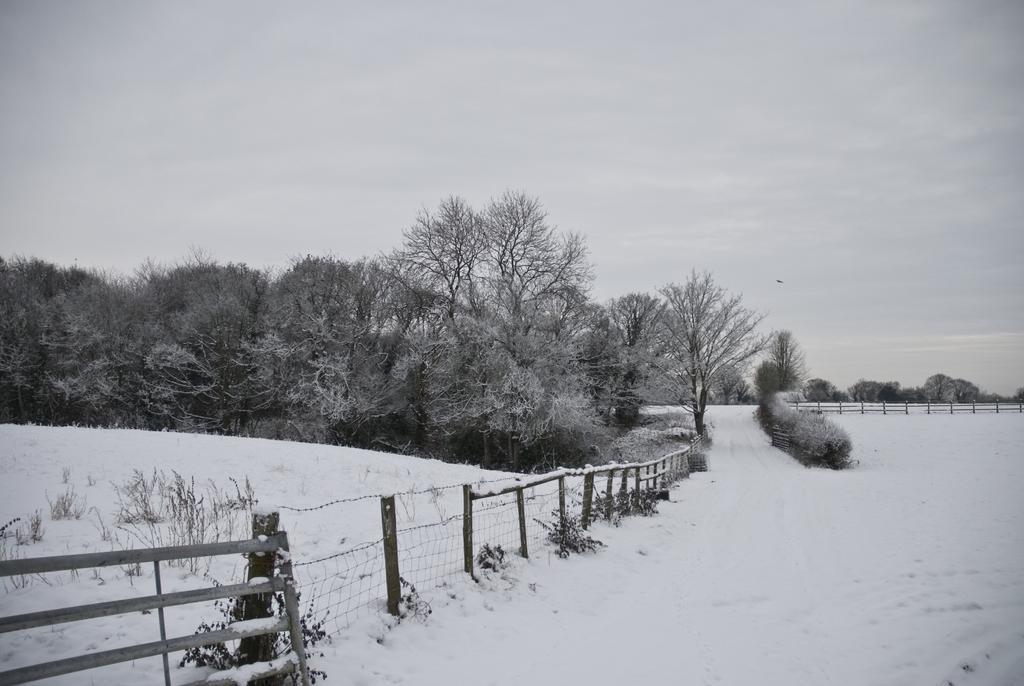Please provide a concise description of this image. It is a black and white picture. In the front of the image there is a railing, snow and plants. In the background of the image there are trees, railing, plants and cloudy sky. Land is covered with snow.  